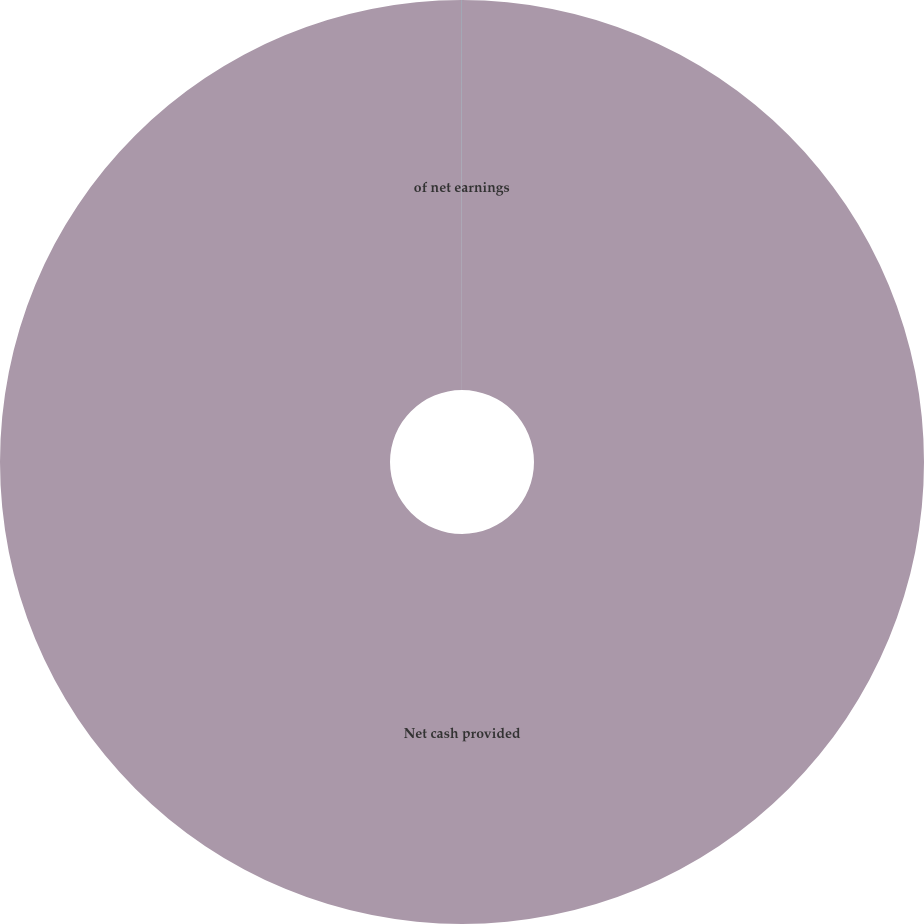Convert chart. <chart><loc_0><loc_0><loc_500><loc_500><pie_chart><fcel>Net cash provided<fcel>of net earnings<nl><fcel>99.98%<fcel>0.02%<nl></chart> 